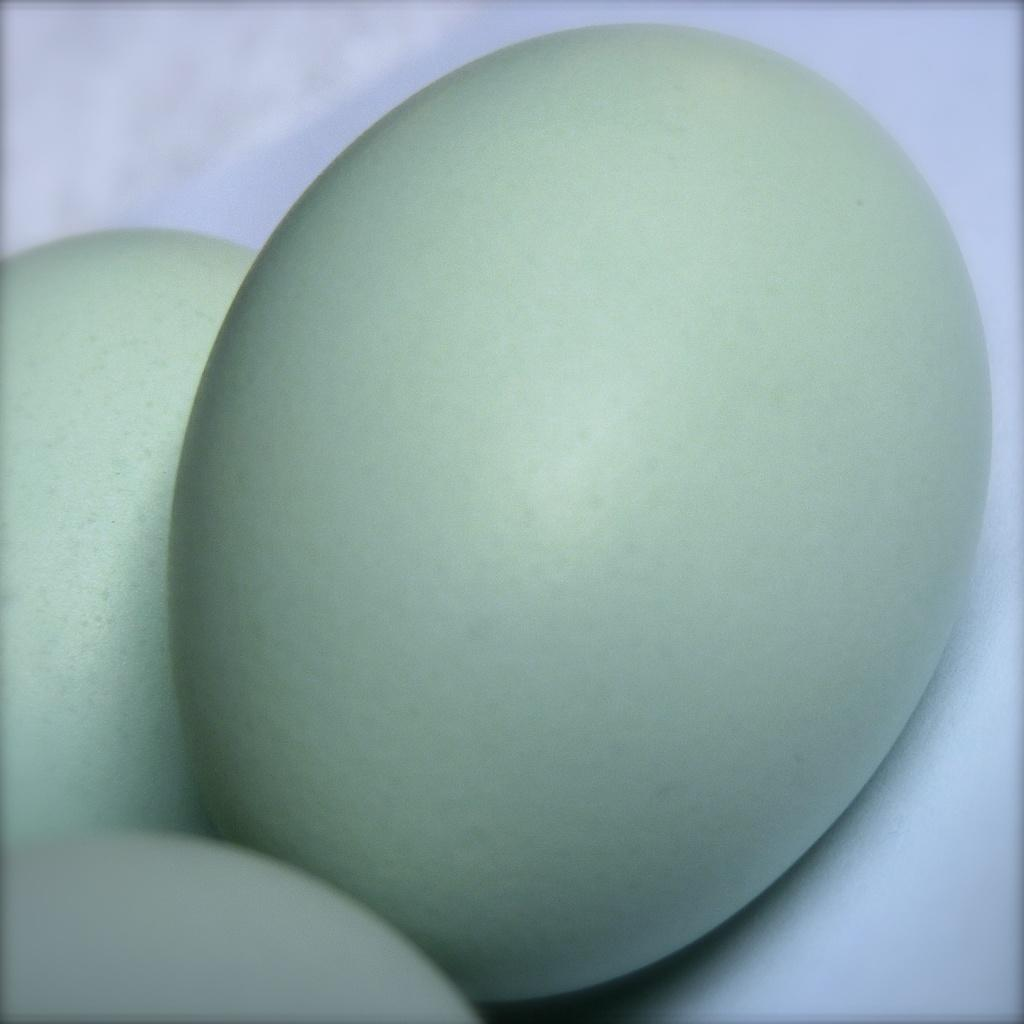How many eggs are visible in the image? There are three eggs in the image. What is the color of the surface on which the eggs are placed? The eggs are on a white surface. What type of drink is being served in the image? There is no drink present in the image; it only features three eggs on a white surface. 